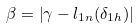Convert formula to latex. <formula><loc_0><loc_0><loc_500><loc_500>\beta = \left | \gamma - l _ { 1 n } ( \delta _ { 1 h } ) \right |</formula> 